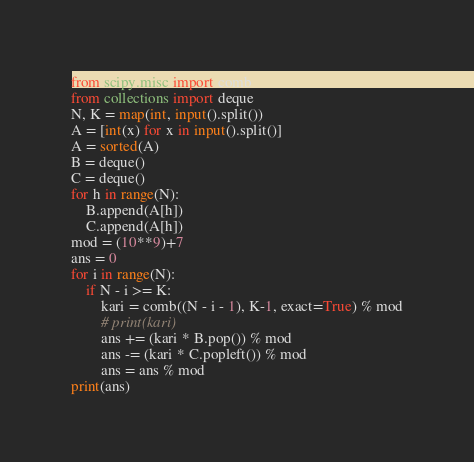Convert code to text. <code><loc_0><loc_0><loc_500><loc_500><_Python_>from scipy.misc import comb
from collections import deque
N, K = map(int, input().split())
A = [int(x) for x in input().split()]
A = sorted(A)
B = deque()
C = deque()
for h in range(N):
    B.append(A[h])
    C.append(A[h])
mod = (10**9)+7
ans = 0
for i in range(N):
    if N - i >= K:
        kari = comb((N - i - 1), K-1, exact=True) % mod
        # print(kari)
        ans += (kari * B.pop()) % mod
        ans -= (kari * C.popleft()) % mod
        ans = ans % mod
print(ans)
</code> 